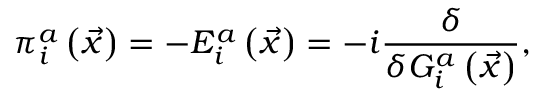Convert formula to latex. <formula><loc_0><loc_0><loc_500><loc_500>\pi _ { i } ^ { a } \left ( \vec { x } \right ) = - E _ { i } ^ { a } \left ( \vec { x } \right ) = - i \frac { \delta } { \delta G _ { i } ^ { a } \left ( \vec { x } \right ) } ,</formula> 